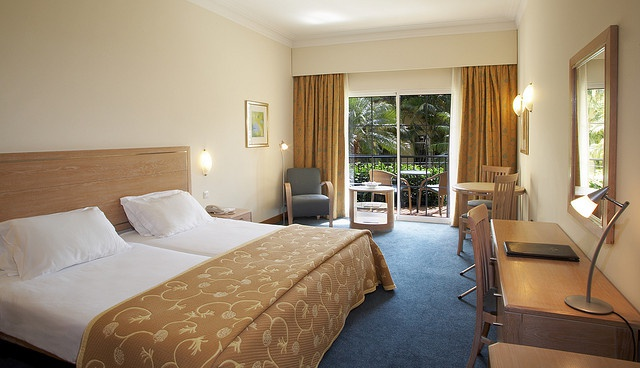Describe the objects in this image and their specific colors. I can see bed in gray, darkgray, tan, and brown tones, chair in gray, brown, black, and maroon tones, chair in gray and black tones, chair in gray and brown tones, and book in gray and black tones in this image. 